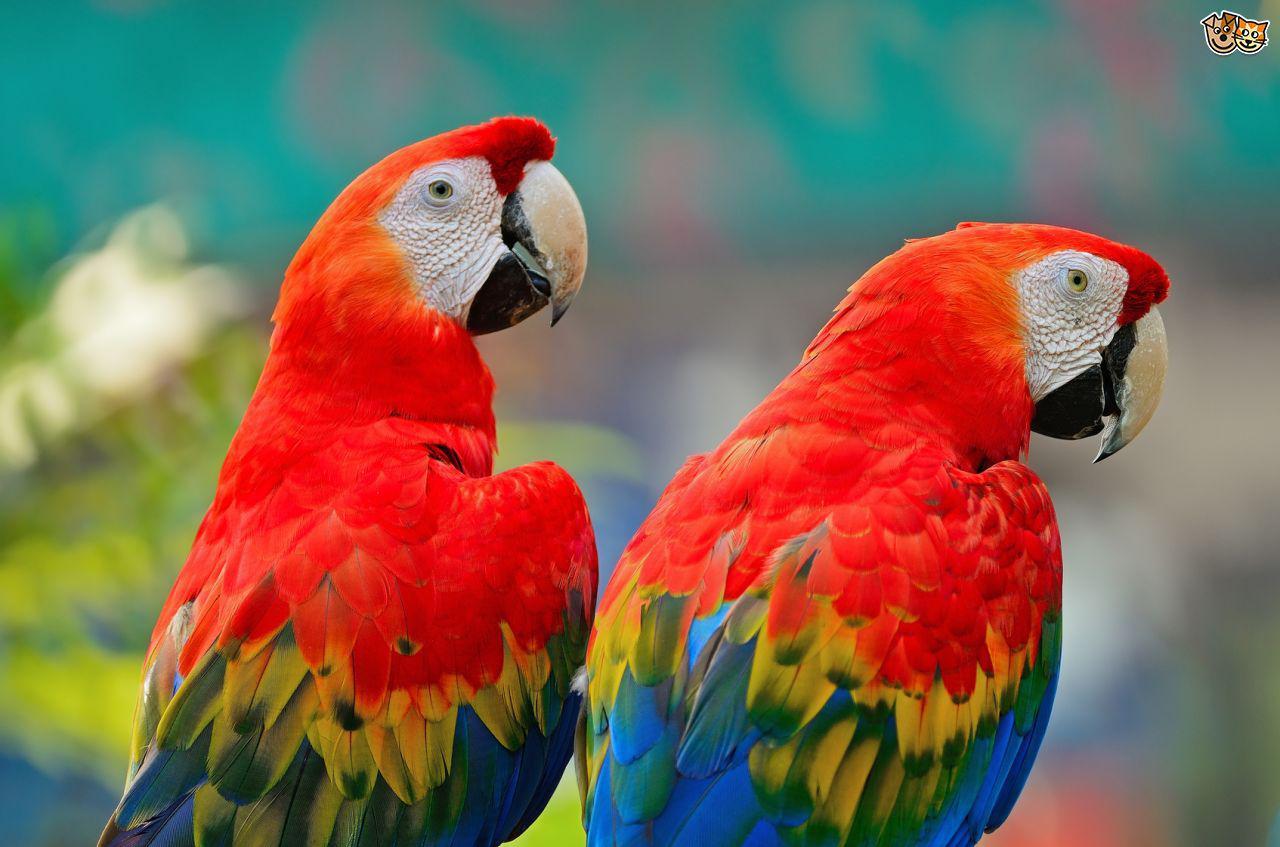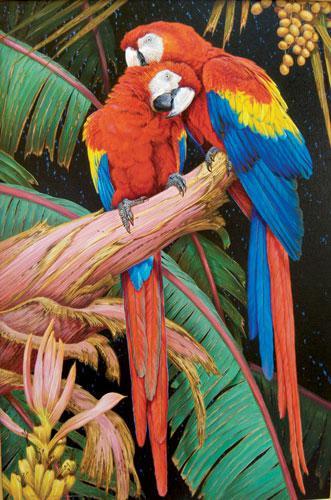The first image is the image on the left, the second image is the image on the right. Considering the images on both sides, is "The left image contains two parrots perched on a branch." valid? Answer yes or no. No. 